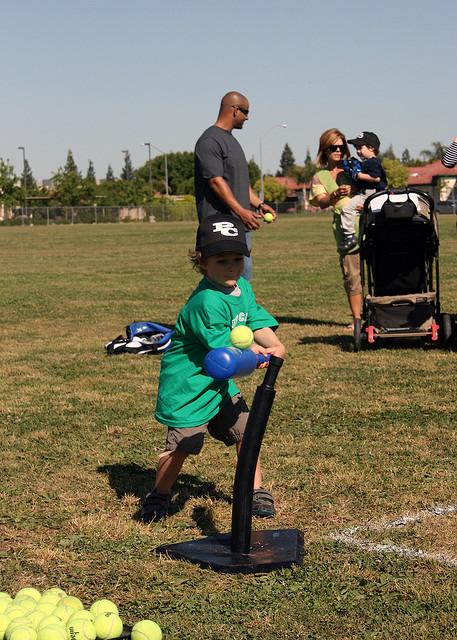Is the sky clear?
Give a very brief answer. Yes. What is the girl holding in her hands?
Give a very brief answer. Bat. Are those cleats?
Answer briefly. No. How many children are visible?
Concise answer only. 2. What type of balls are in the photo?
Quick response, please. Tennis. What is the ball sitting on?
Answer briefly. Tee. 